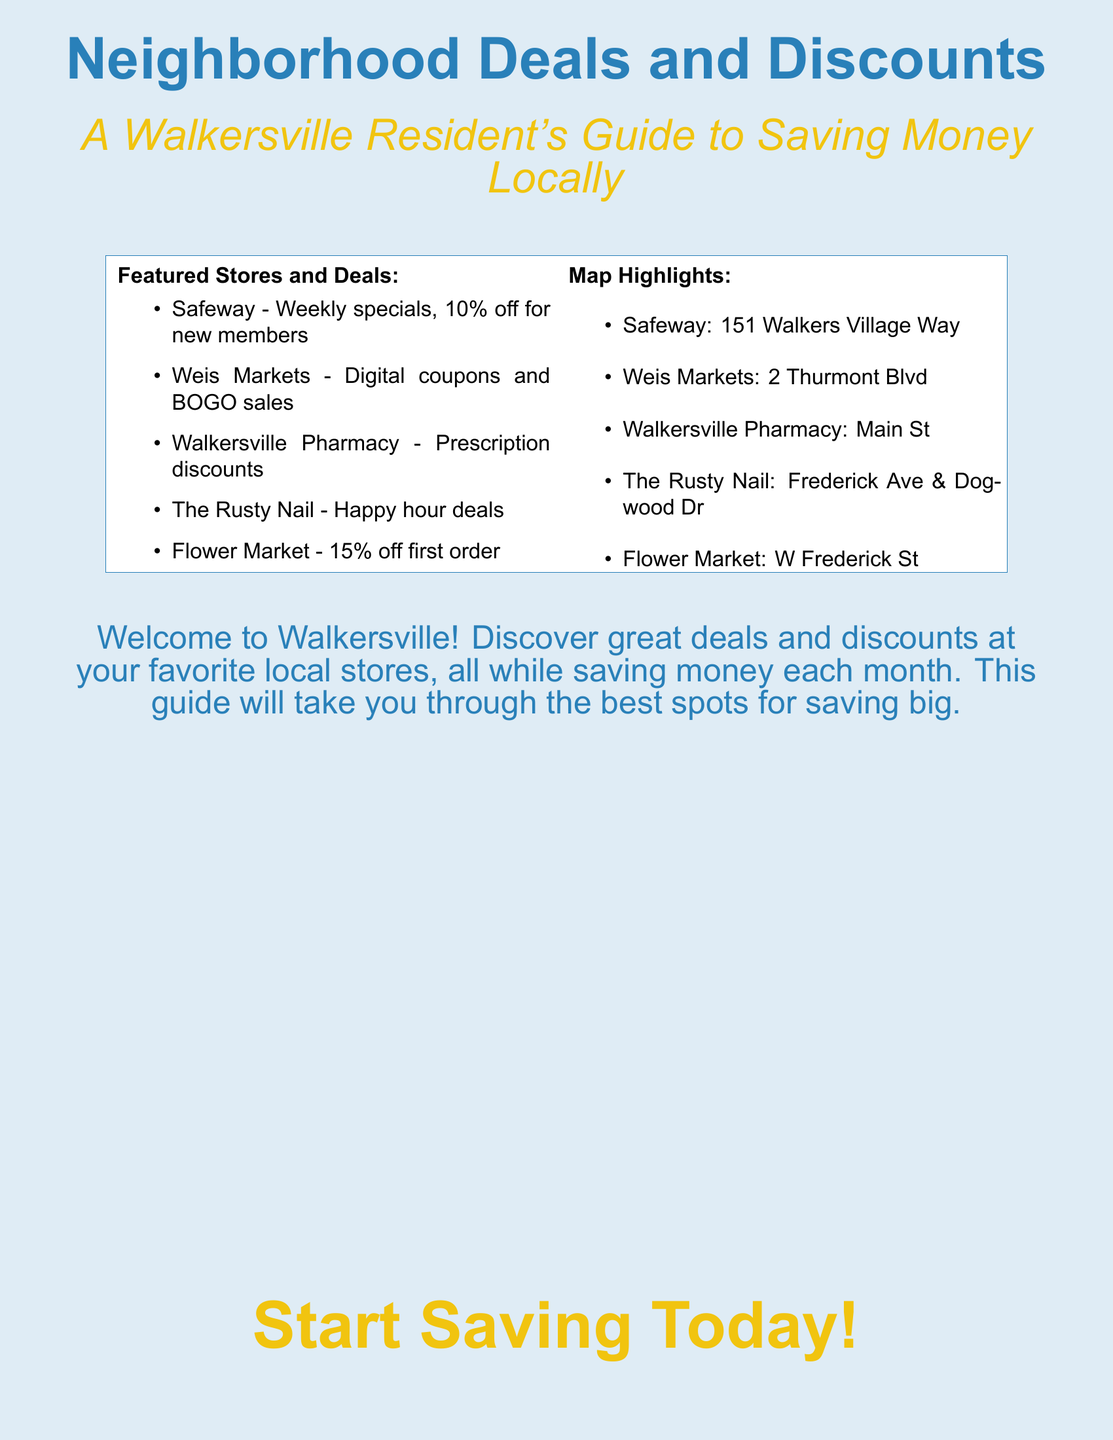What is the title of the book? The title is prominently displayed at the top of the cover.
Answer: Neighborhood Deals and Discounts What is the subtitle of the book? The subtitle is located just below the title, explaining the book's purpose.
Answer: A Walkersville Resident's Guide to Saving Money Locally What discount do new members get at Safeway? This information is found in the list of featured stores and deals.
Answer: 10% off Which store is associated with happy hour deals? This detail is listed under the featured stores section, indicating special promotions.
Answer: The Rusty Nail What is located at 151 Walkers Village Way? This address corresponds to one of the highlighted stores on the map.
Answer: Safeway How much off is the first order at Flower Market? The amount of the discount is given in the featured stores list.
Answer: 15% What type of coupons can be found at Weis Markets? This information indicates the promotional offers available at this store.
Answer: Digital coupons Which street is Walkersville Pharmacy on? This information is pertaining to the location of the pharmacy in Walkersville.
Answer: Main St What call to action is at the bottom of the cover? This is a motivation for readers to engage with the material.
Answer: Start Saving Today! 